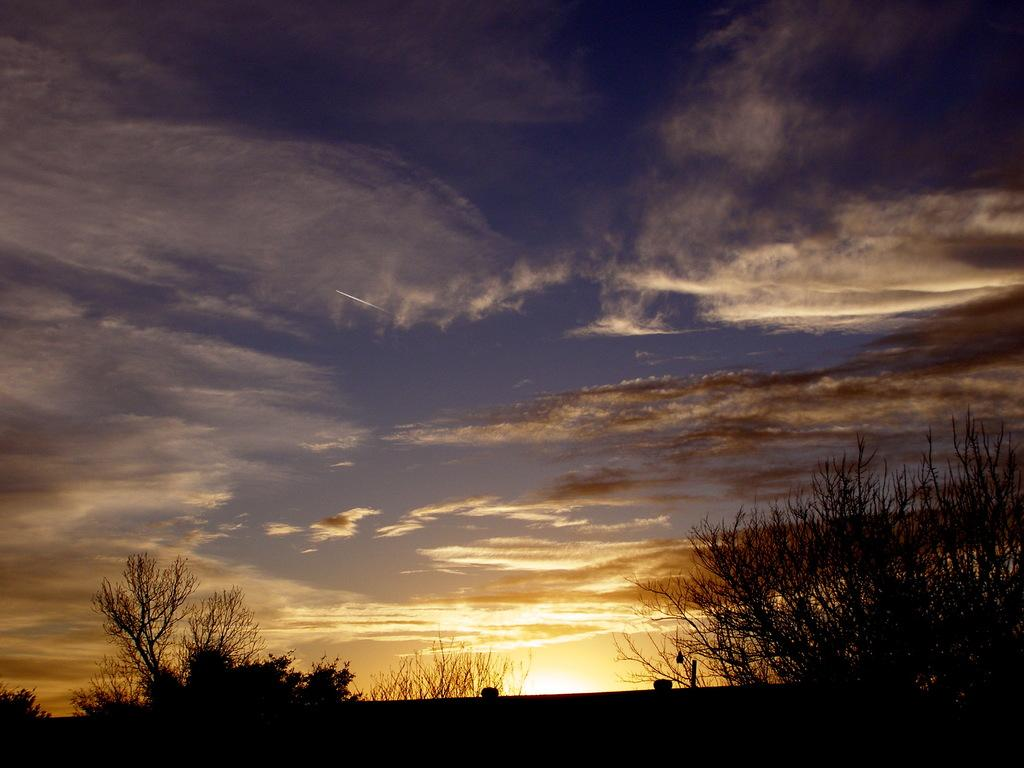What type of living organisms can be seen in the image? Plants can be seen in the image. What part of the natural environment is visible in the image? The sky is visible in the background of the image. What shape is the print on the plants in the image? There is no print on the plants in the image, as they are living organisms and not printed materials. How many bees can be seen buzzing around the plants in the image? There are no bees present in the image; only plants and the sky are visible. 